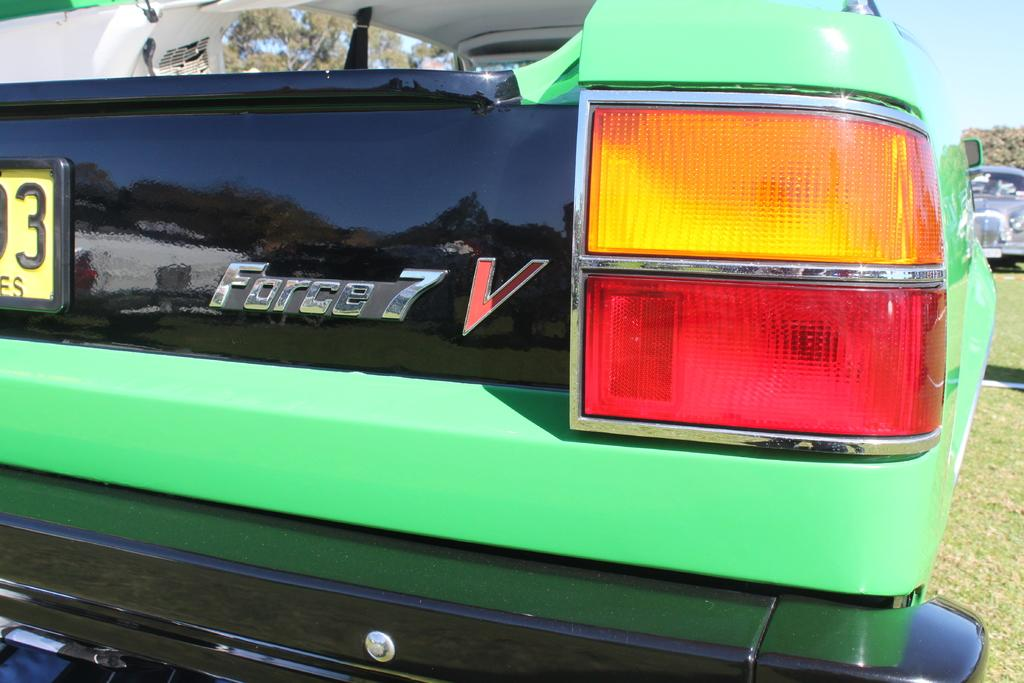What types of objects are on the ground in the image? There are vehicles on the ground in the image. What can be seen in the distance behind the vehicles? Trees and the sky are visible in the background of the image. How many ladybugs are crawling on the trees in the image? There are no ladybugs visible in the image; only trees and the sky are present in the background. 